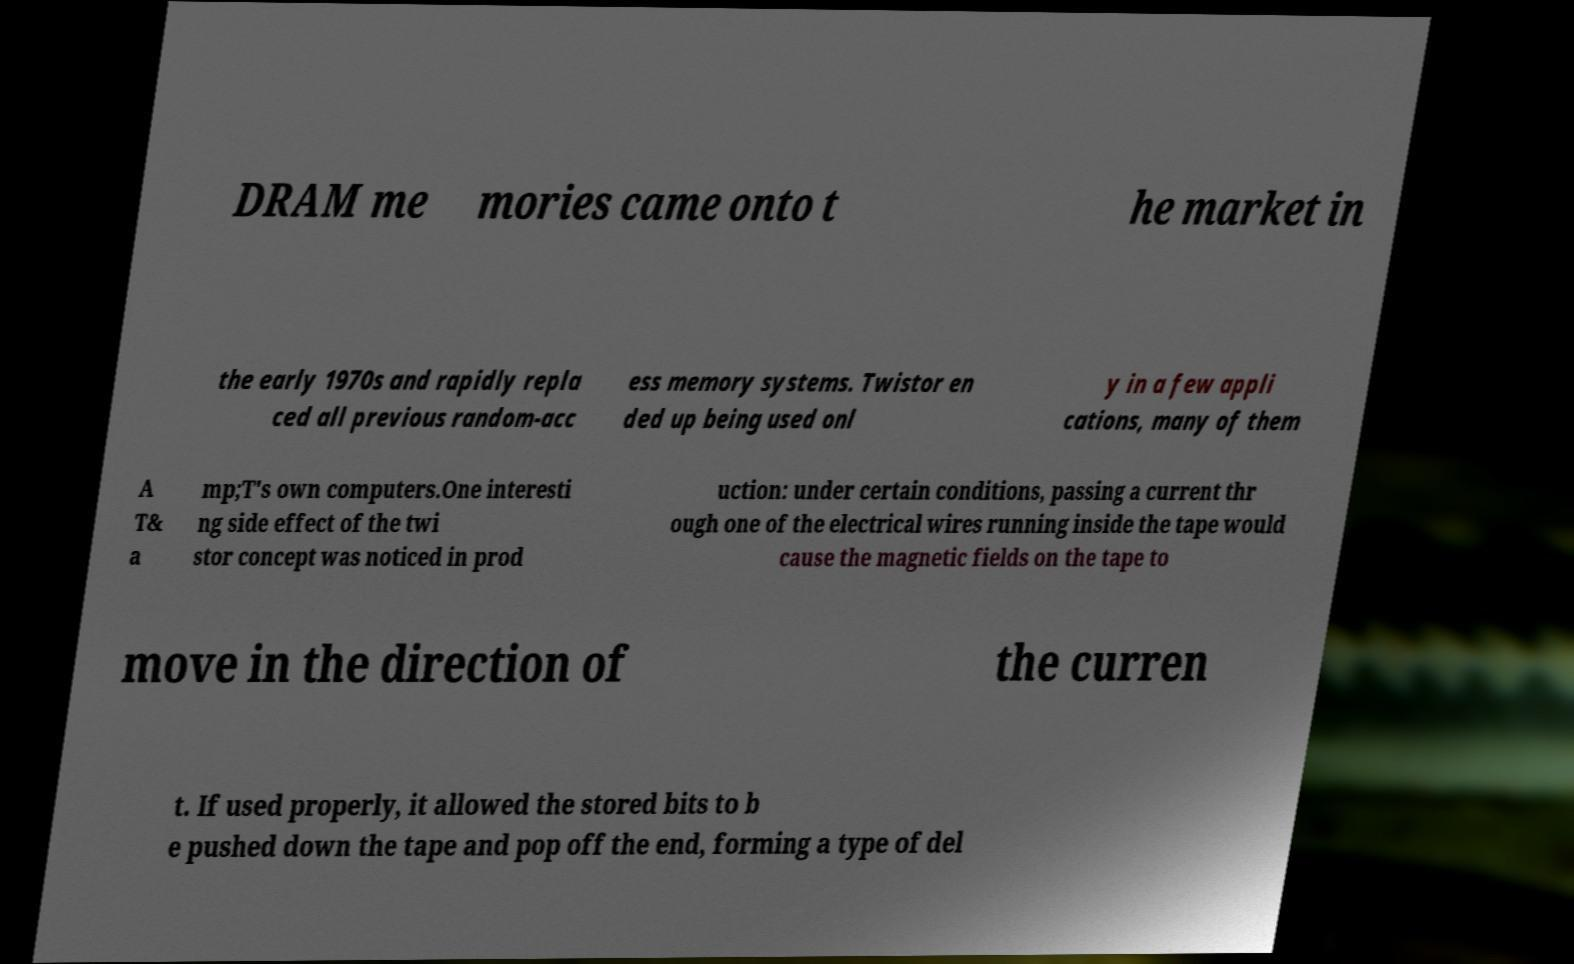I need the written content from this picture converted into text. Can you do that? DRAM me mories came onto t he market in the early 1970s and rapidly repla ced all previous random-acc ess memory systems. Twistor en ded up being used onl y in a few appli cations, many of them A T& a mp;T's own computers.One interesti ng side effect of the twi stor concept was noticed in prod uction: under certain conditions, passing a current thr ough one of the electrical wires running inside the tape would cause the magnetic fields on the tape to move in the direction of the curren t. If used properly, it allowed the stored bits to b e pushed down the tape and pop off the end, forming a type of del 